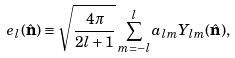Convert formula to latex. <formula><loc_0><loc_0><loc_500><loc_500>e _ { l } ( \hat { \mathbf n } ) \equiv \sqrt { \frac { 4 \pi } { 2 l + 1 } } \sum _ { m = - l } ^ { l } a _ { l m } Y _ { l m } ( \hat { \mathbf n } ) ,</formula> 